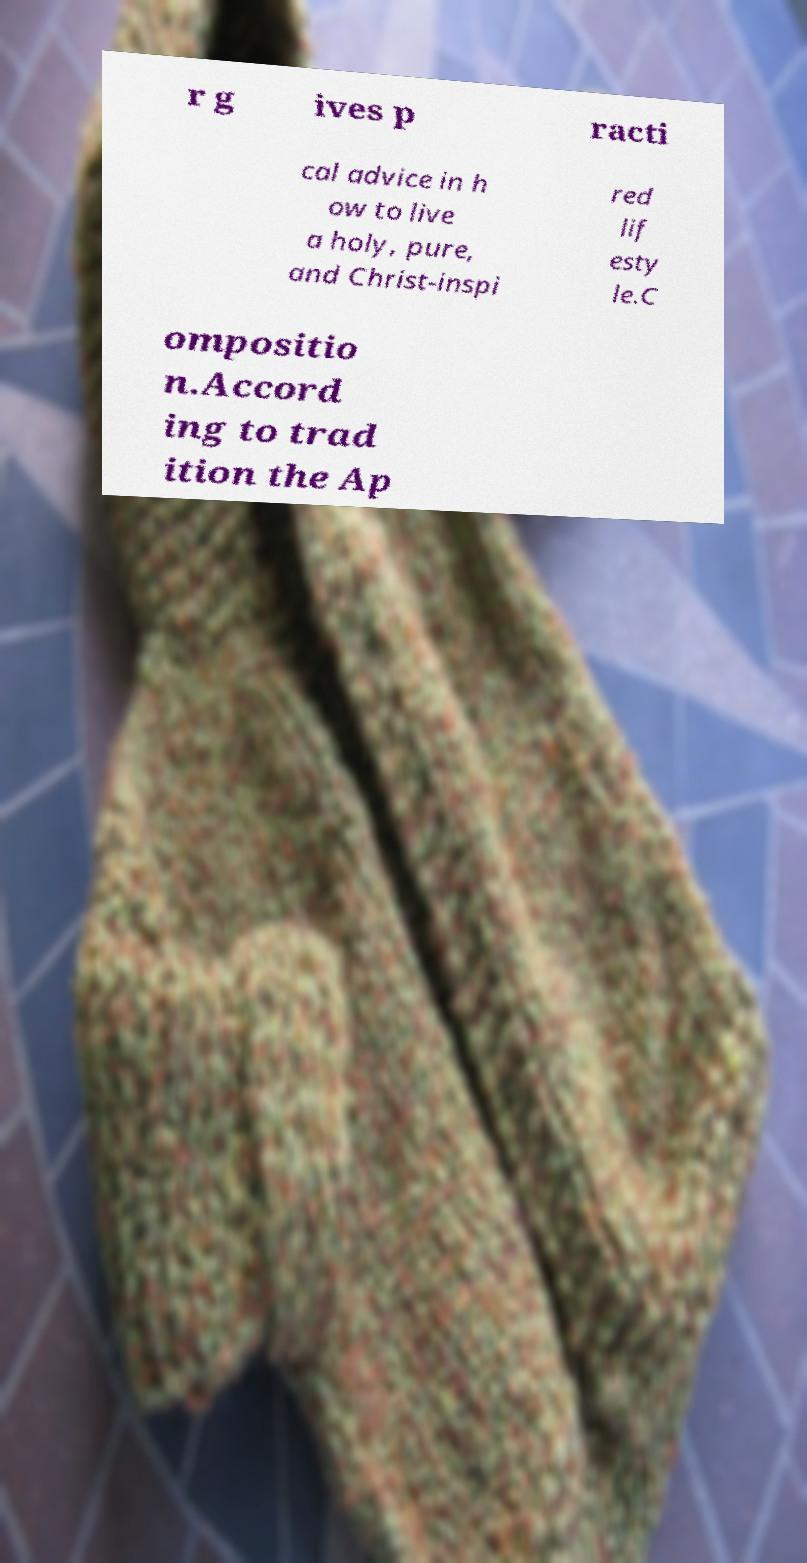What messages or text are displayed in this image? I need them in a readable, typed format. r g ives p racti cal advice in h ow to live a holy, pure, and Christ-inspi red lif esty le.C ompositio n.Accord ing to trad ition the Ap 